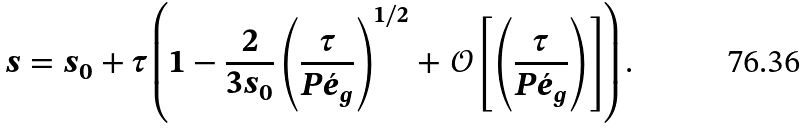Convert formula to latex. <formula><loc_0><loc_0><loc_500><loc_500>s = s _ { 0 } + \tau \left ( 1 - \frac { 2 } { 3 s _ { 0 } } \left ( \frac { \tau } { P \acute { e } _ { g } } \right ) ^ { 1 / 2 } + \mathcal { O } \left [ \left ( \frac { \tau } { P \acute { e } _ { g } } \right ) \right ] \right ) .</formula> 